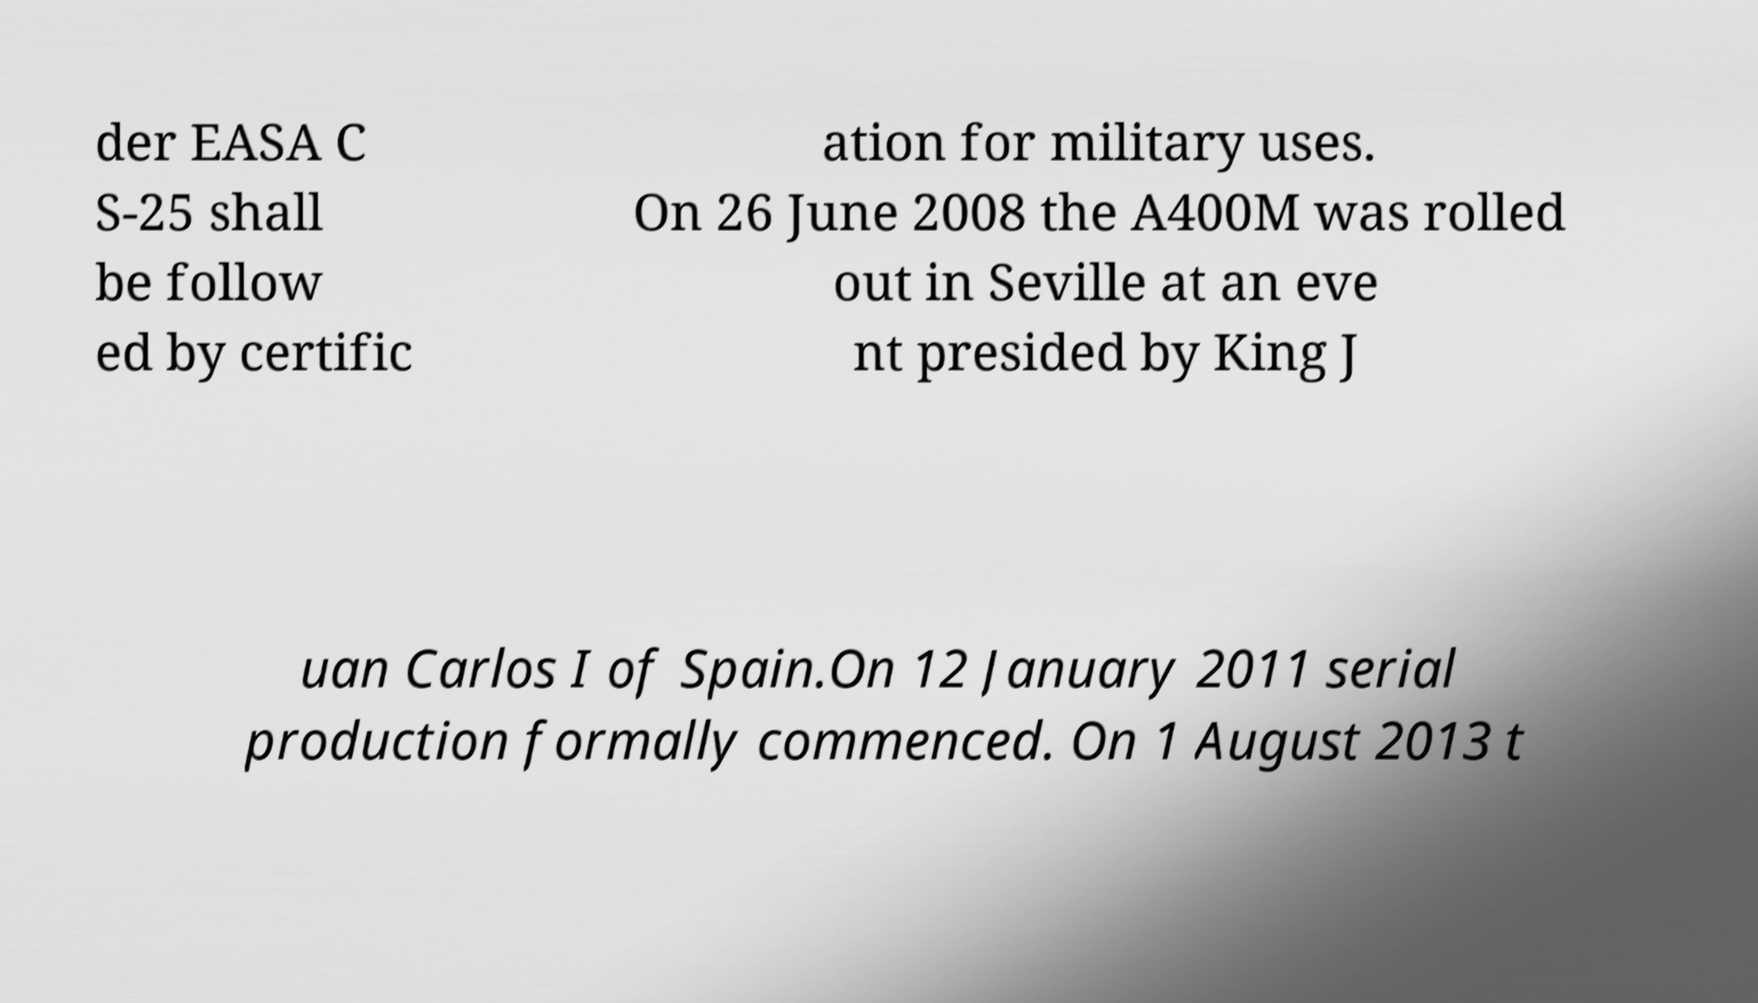Can you accurately transcribe the text from the provided image for me? der EASA C S-25 shall be follow ed by certific ation for military uses. On 26 June 2008 the A400M was rolled out in Seville at an eve nt presided by King J uan Carlos I of Spain.On 12 January 2011 serial production formally commenced. On 1 August 2013 t 